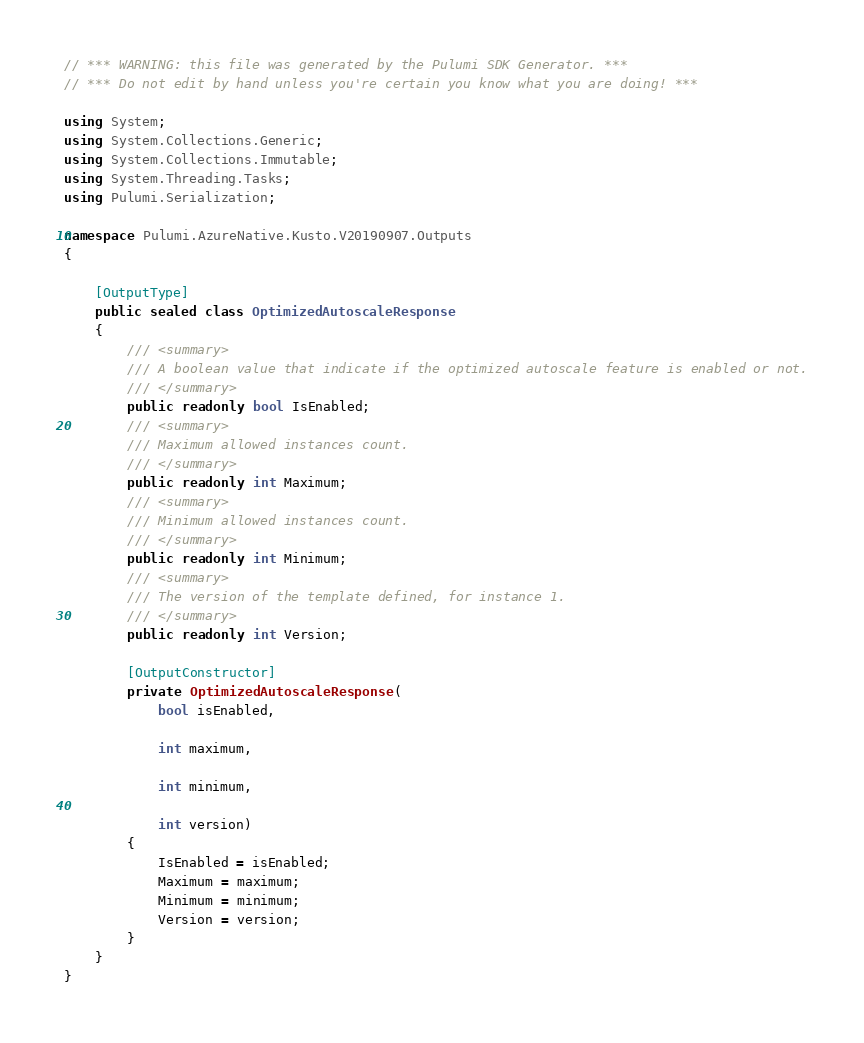Convert code to text. <code><loc_0><loc_0><loc_500><loc_500><_C#_>// *** WARNING: this file was generated by the Pulumi SDK Generator. ***
// *** Do not edit by hand unless you're certain you know what you are doing! ***

using System;
using System.Collections.Generic;
using System.Collections.Immutable;
using System.Threading.Tasks;
using Pulumi.Serialization;

namespace Pulumi.AzureNative.Kusto.V20190907.Outputs
{

    [OutputType]
    public sealed class OptimizedAutoscaleResponse
    {
        /// <summary>
        /// A boolean value that indicate if the optimized autoscale feature is enabled or not.
        /// </summary>
        public readonly bool IsEnabled;
        /// <summary>
        /// Maximum allowed instances count.
        /// </summary>
        public readonly int Maximum;
        /// <summary>
        /// Minimum allowed instances count.
        /// </summary>
        public readonly int Minimum;
        /// <summary>
        /// The version of the template defined, for instance 1.
        /// </summary>
        public readonly int Version;

        [OutputConstructor]
        private OptimizedAutoscaleResponse(
            bool isEnabled,

            int maximum,

            int minimum,

            int version)
        {
            IsEnabled = isEnabled;
            Maximum = maximum;
            Minimum = minimum;
            Version = version;
        }
    }
}
</code> 